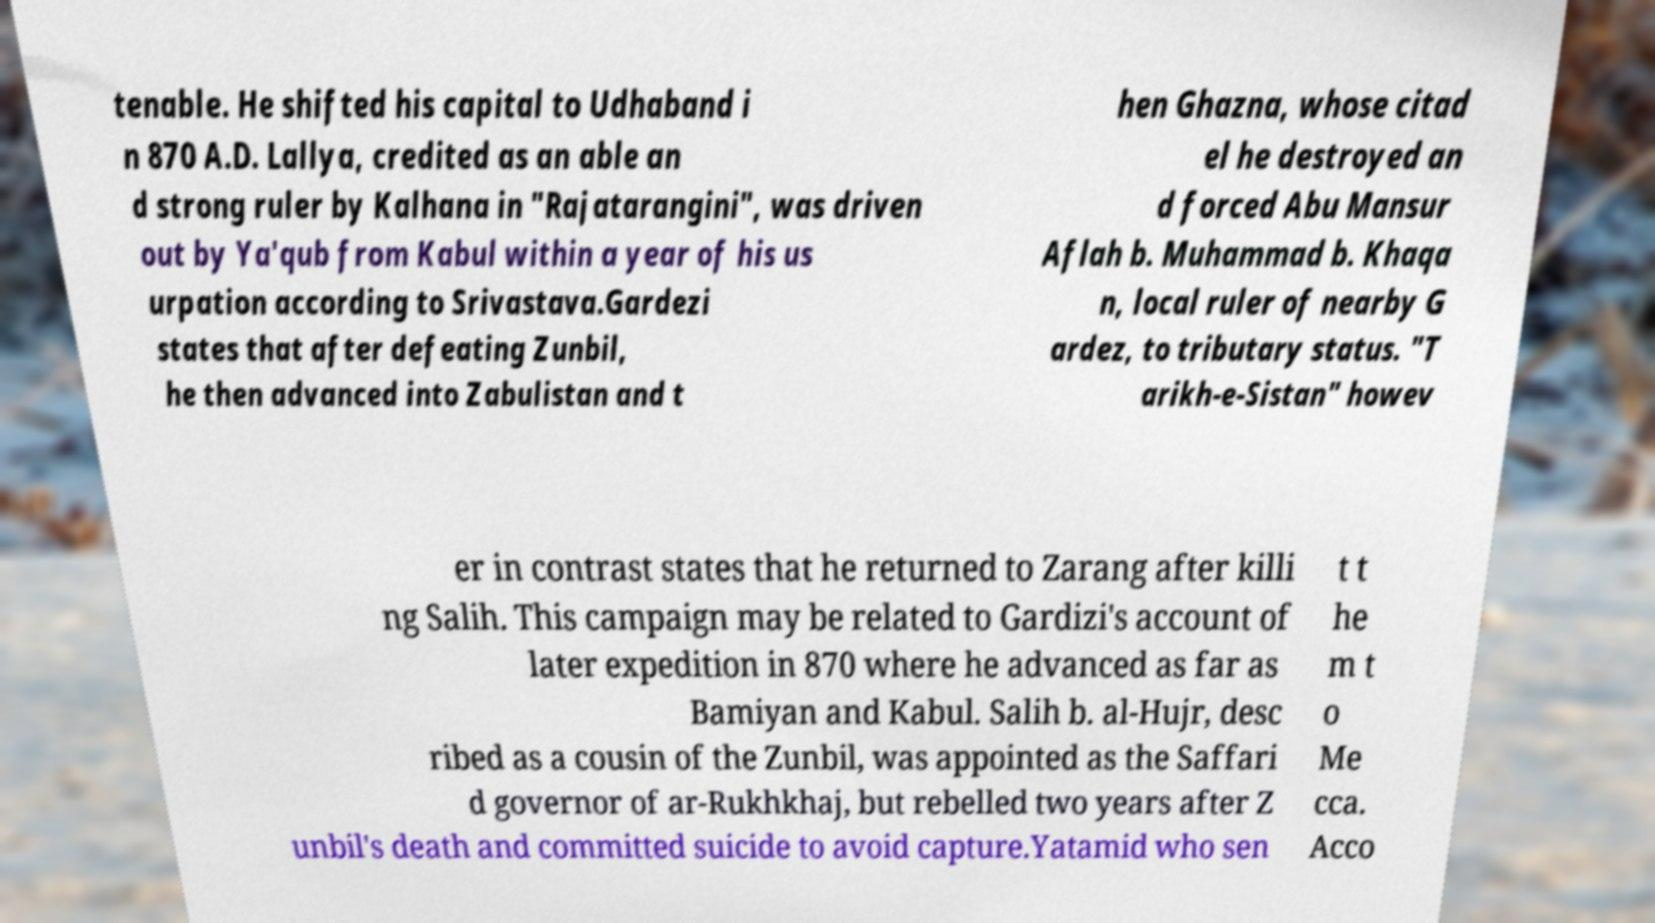For documentation purposes, I need the text within this image transcribed. Could you provide that? tenable. He shifted his capital to Udhaband i n 870 A.D. Lallya, credited as an able an d strong ruler by Kalhana in "Rajatarangini", was driven out by Ya'qub from Kabul within a year of his us urpation according to Srivastava.Gardezi states that after defeating Zunbil, he then advanced into Zabulistan and t hen Ghazna, whose citad el he destroyed an d forced Abu Mansur Aflah b. Muhammad b. Khaqa n, local ruler of nearby G ardez, to tributary status. "T arikh-e-Sistan" howev er in contrast states that he returned to Zarang after killi ng Salih. This campaign may be related to Gardizi's account of later expedition in 870 where he advanced as far as Bamiyan and Kabul. Salih b. al-Hujr, desc ribed as a cousin of the Zunbil, was appointed as the Saffari d governor of ar-Rukhkhaj, but rebelled two years after Z unbil's death and committed suicide to avoid capture.Yatamid who sen t t he m t o Me cca. Acco 